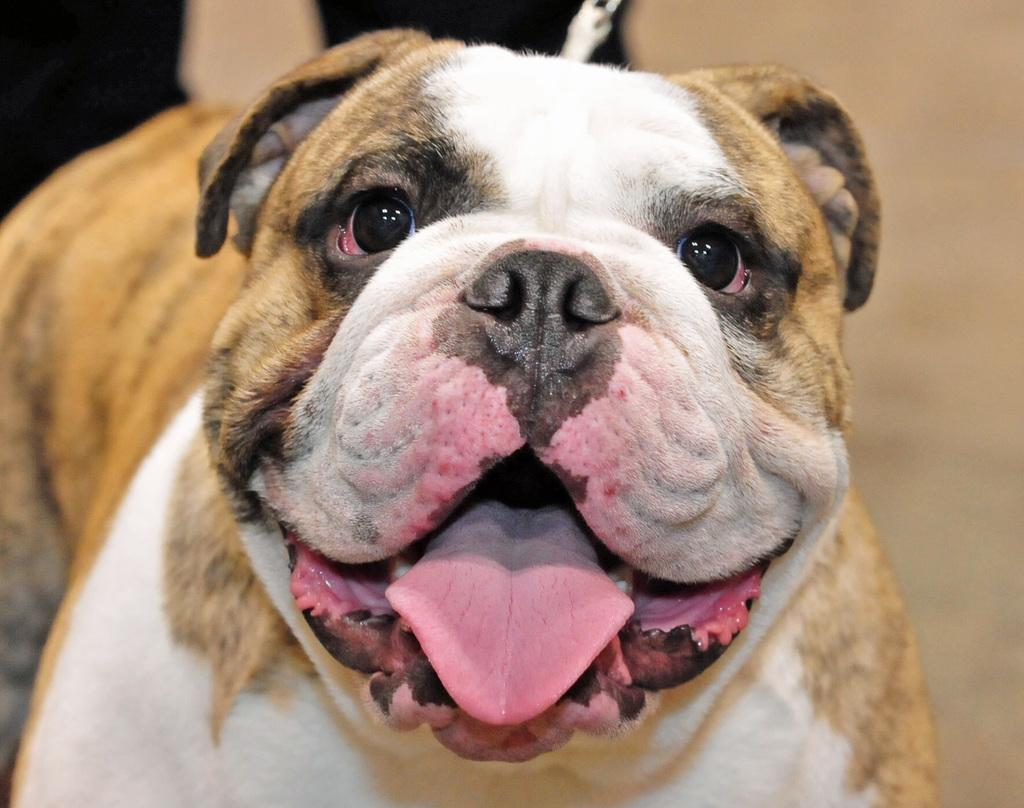What type of animal is present in the image? There is a dog in the image. What type of mask is the zebra wearing in the image? There is no zebra or mask present in the image; it features a dog. 